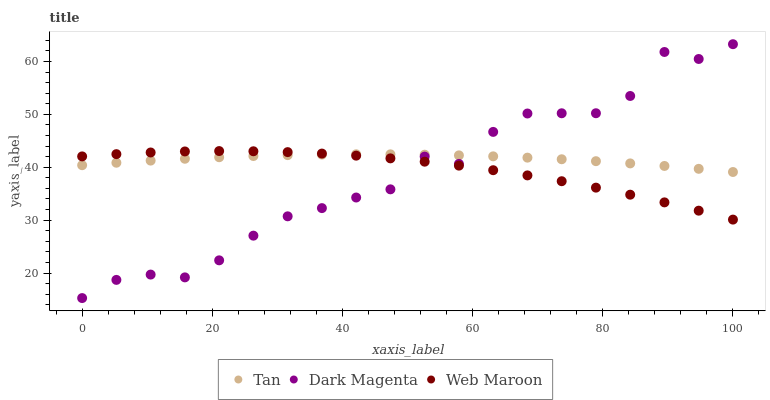Does Dark Magenta have the minimum area under the curve?
Answer yes or no. Yes. Does Tan have the maximum area under the curve?
Answer yes or no. Yes. Does Web Maroon have the minimum area under the curve?
Answer yes or no. No. Does Web Maroon have the maximum area under the curve?
Answer yes or no. No. Is Tan the smoothest?
Answer yes or no. Yes. Is Dark Magenta the roughest?
Answer yes or no. Yes. Is Web Maroon the smoothest?
Answer yes or no. No. Is Web Maroon the roughest?
Answer yes or no. No. Does Dark Magenta have the lowest value?
Answer yes or no. Yes. Does Web Maroon have the lowest value?
Answer yes or no. No. Does Dark Magenta have the highest value?
Answer yes or no. Yes. Does Web Maroon have the highest value?
Answer yes or no. No. Does Dark Magenta intersect Tan?
Answer yes or no. Yes. Is Dark Magenta less than Tan?
Answer yes or no. No. Is Dark Magenta greater than Tan?
Answer yes or no. No. 